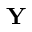<formula> <loc_0><loc_0><loc_500><loc_500>Y</formula> 